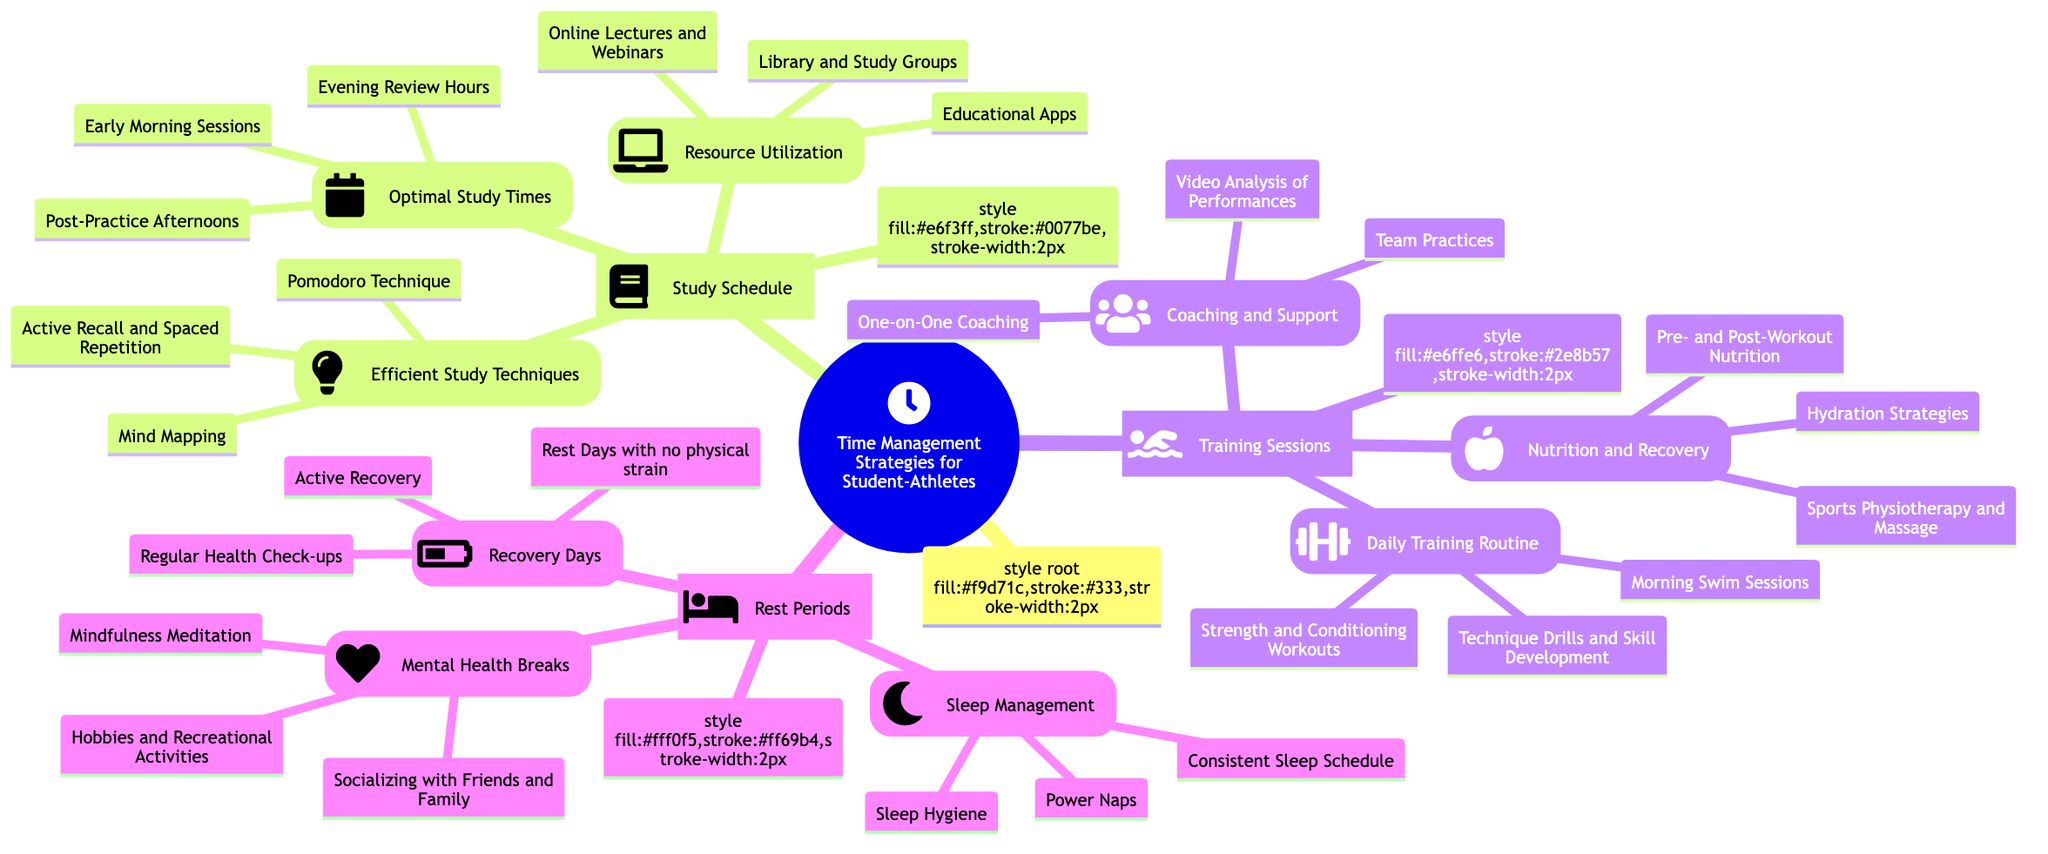What are the three main sections of the mind map? The mind map is divided into three main sections: Study Schedule, Training Sessions, and Rest Periods.
Answer: Study Schedule, Training Sessions, Rest Periods How many optimal study times are listed? There are three optimal study times mentioned under the Study Schedule section: Early Morning Sessions, Post-Practice Afternoons, and Evening Review Hours.
Answer: 3 What technique is mentioned for efficient study? The mind map lists three efficient study techniques, one of which is the Pomodoro Technique, among others including Active Recall and Spaced Repetition, and Mind Mapping.
Answer: Pomodoro Technique What type of support is categorized under Coaching and Support? The mind map indicates three types of support, including One-on-One Coaching as well as Team Practices and Video Analysis of Performances.
Answer: One-on-One Coaching What is included in Nutrition and Recovery? Under Nutrition and Recovery, the mind map highlights Pre- and Post-Workout Nutrition as one of the three components, along with Hydration Strategies and Sports Physiotherapy and Massage.
Answer: Pre- and Post-Workout Nutrition How are sleep management strategies grouped? The strategies for sleep management are included in three main areas: Consistent Sleep Schedule, Power Naps, and Sleep Hygiene, as listed under Rest Periods.
Answer: Consistent Sleep Schedule What is one example of a mental health break? The mind map lists Mindfulness Meditation as one example of a mental health break within the Mental Health Breaks section.
Answer: Mindfulness Meditation How many recovery days strategies are there? There are three strategies mentioned under Recovery Days: Active Recovery, Rest Days with no physical strain, and Regular Health Check-ups.
Answer: 3 What is the relationship between Study Schedule and Resource Utilization? The Study Schedule section includes Resource Utilization as one of its components, indicating that effective use of resources aids in managing study time effectively.
Answer: Resource Utilization 